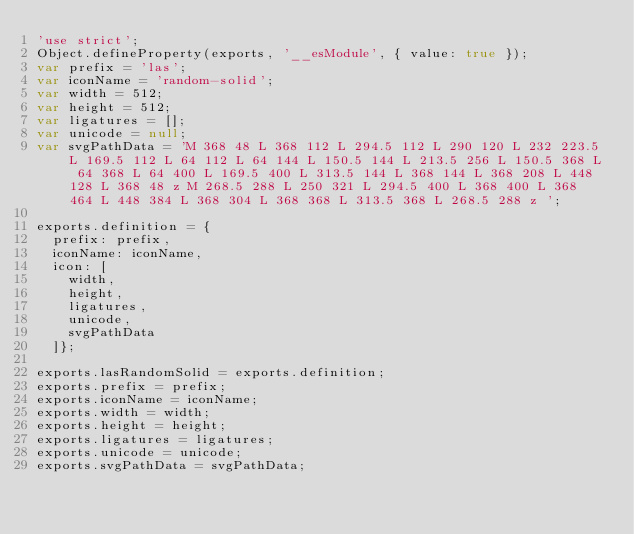Convert code to text. <code><loc_0><loc_0><loc_500><loc_500><_JavaScript_>'use strict';
Object.defineProperty(exports, '__esModule', { value: true });
var prefix = 'las';
var iconName = 'random-solid';
var width = 512;
var height = 512;
var ligatures = [];
var unicode = null;
var svgPathData = 'M 368 48 L 368 112 L 294.5 112 L 290 120 L 232 223.5 L 169.5 112 L 64 112 L 64 144 L 150.5 144 L 213.5 256 L 150.5 368 L 64 368 L 64 400 L 169.5 400 L 313.5 144 L 368 144 L 368 208 L 448 128 L 368 48 z M 268.5 288 L 250 321 L 294.5 400 L 368 400 L 368 464 L 448 384 L 368 304 L 368 368 L 313.5 368 L 268.5 288 z ';

exports.definition = {
  prefix: prefix,
  iconName: iconName,
  icon: [
    width,
    height,
    ligatures,
    unicode,
    svgPathData
  ]};
	
exports.lasRandomSolid = exports.definition;
exports.prefix = prefix;
exports.iconName = iconName;
exports.width = width;
exports.height = height;
exports.ligatures = ligatures;
exports.unicode = unicode;
exports.svgPathData = svgPathData;</code> 